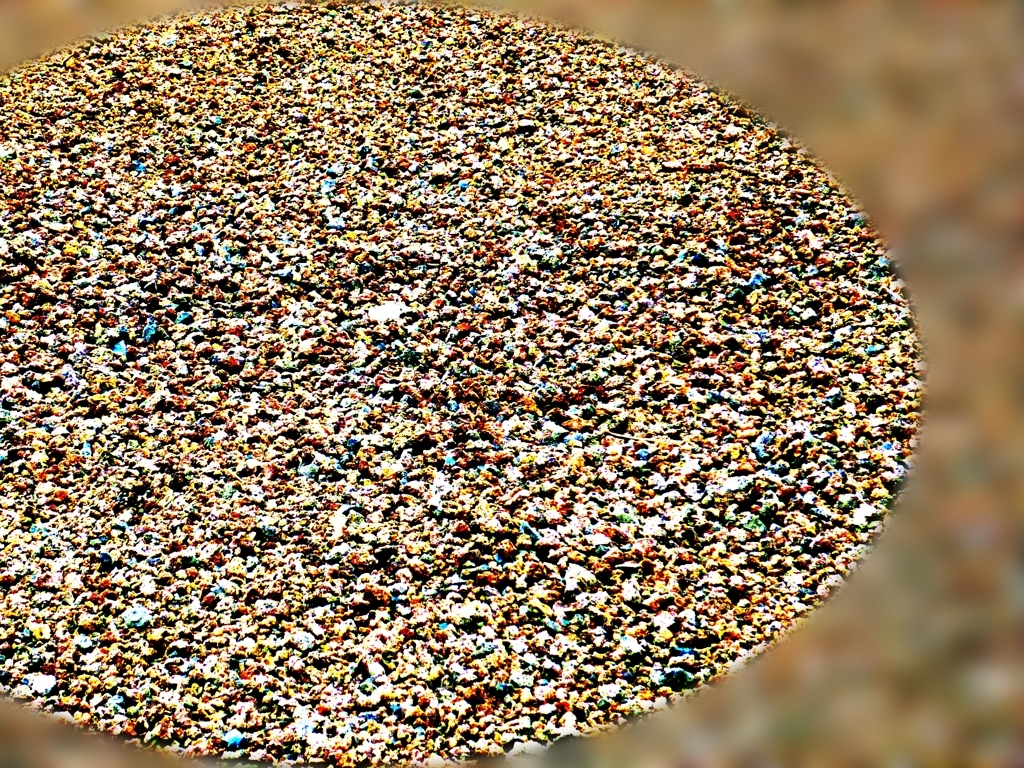Can you guess the nature of the objects shown in the picture? Given the image's abstract and densely populated appearance, it's difficult to determine the exact nature of the objects. They might be anything from a collection of colorful pebbles to a large crowd of people seen from a distant perspective. The true nature would require more context or information. Is there any indication of the scale or perspective in this image? The image doesn't provide clear indicators of scale or perspective, which makes it challenging to ascertain the size of the objects or the photographer's vantage point. However, the uniformity of focus across the surface suggests that the photograph might have been taken from a considerable distance to achieve such a wide field of view. 